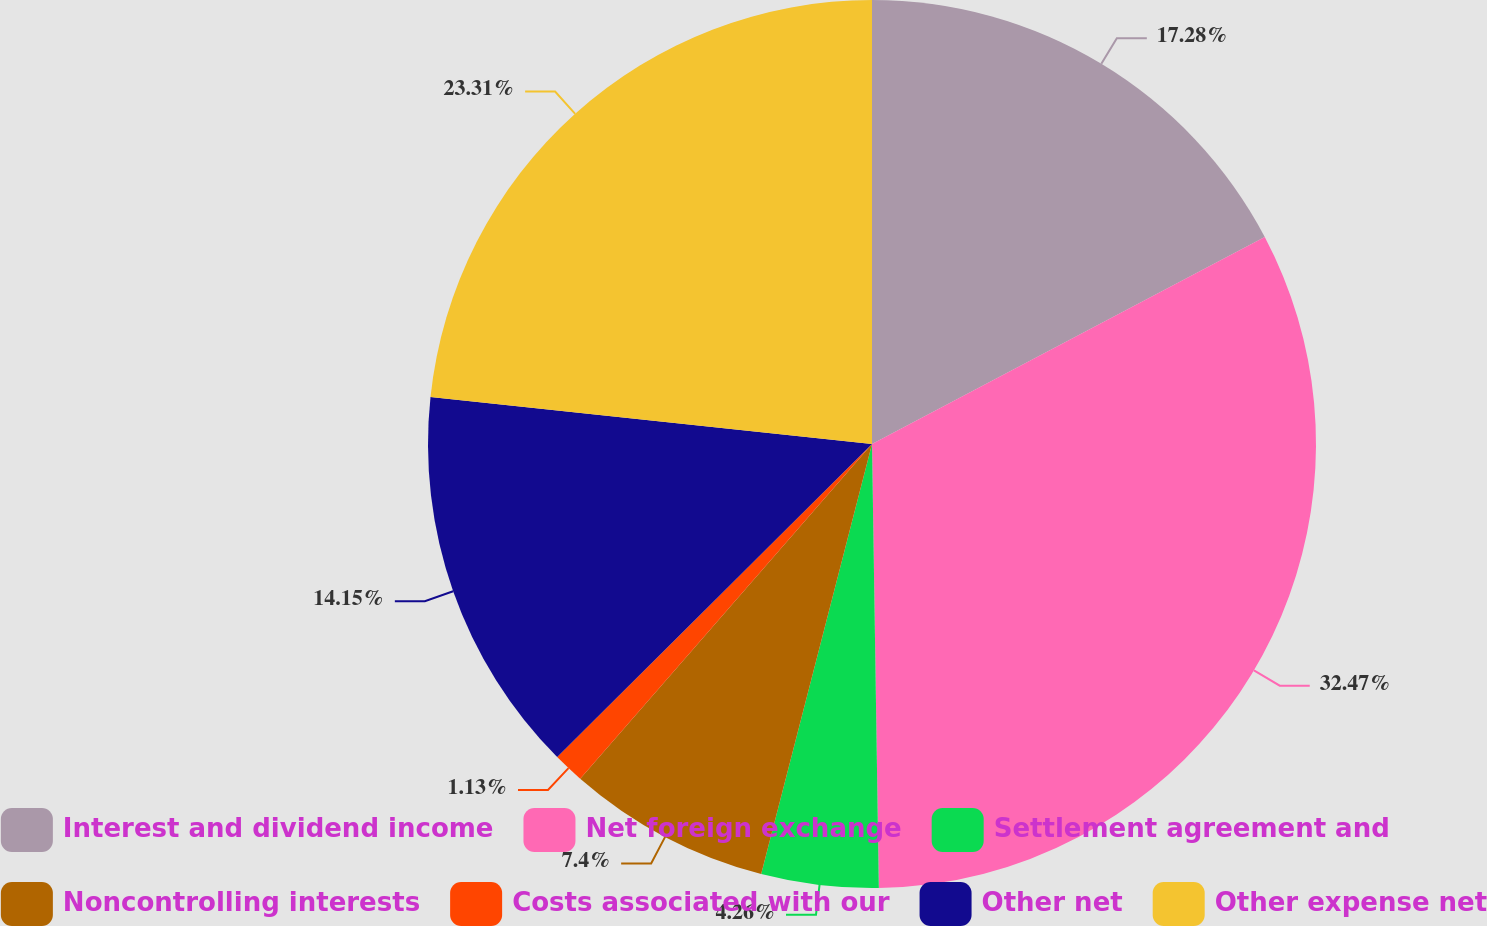Convert chart to OTSL. <chart><loc_0><loc_0><loc_500><loc_500><pie_chart><fcel>Interest and dividend income<fcel>Net foreign exchange<fcel>Settlement agreement and<fcel>Noncontrolling interests<fcel>Costs associated with our<fcel>Other net<fcel>Other expense net<nl><fcel>17.28%<fcel>32.48%<fcel>4.26%<fcel>7.4%<fcel>1.13%<fcel>14.15%<fcel>23.31%<nl></chart> 